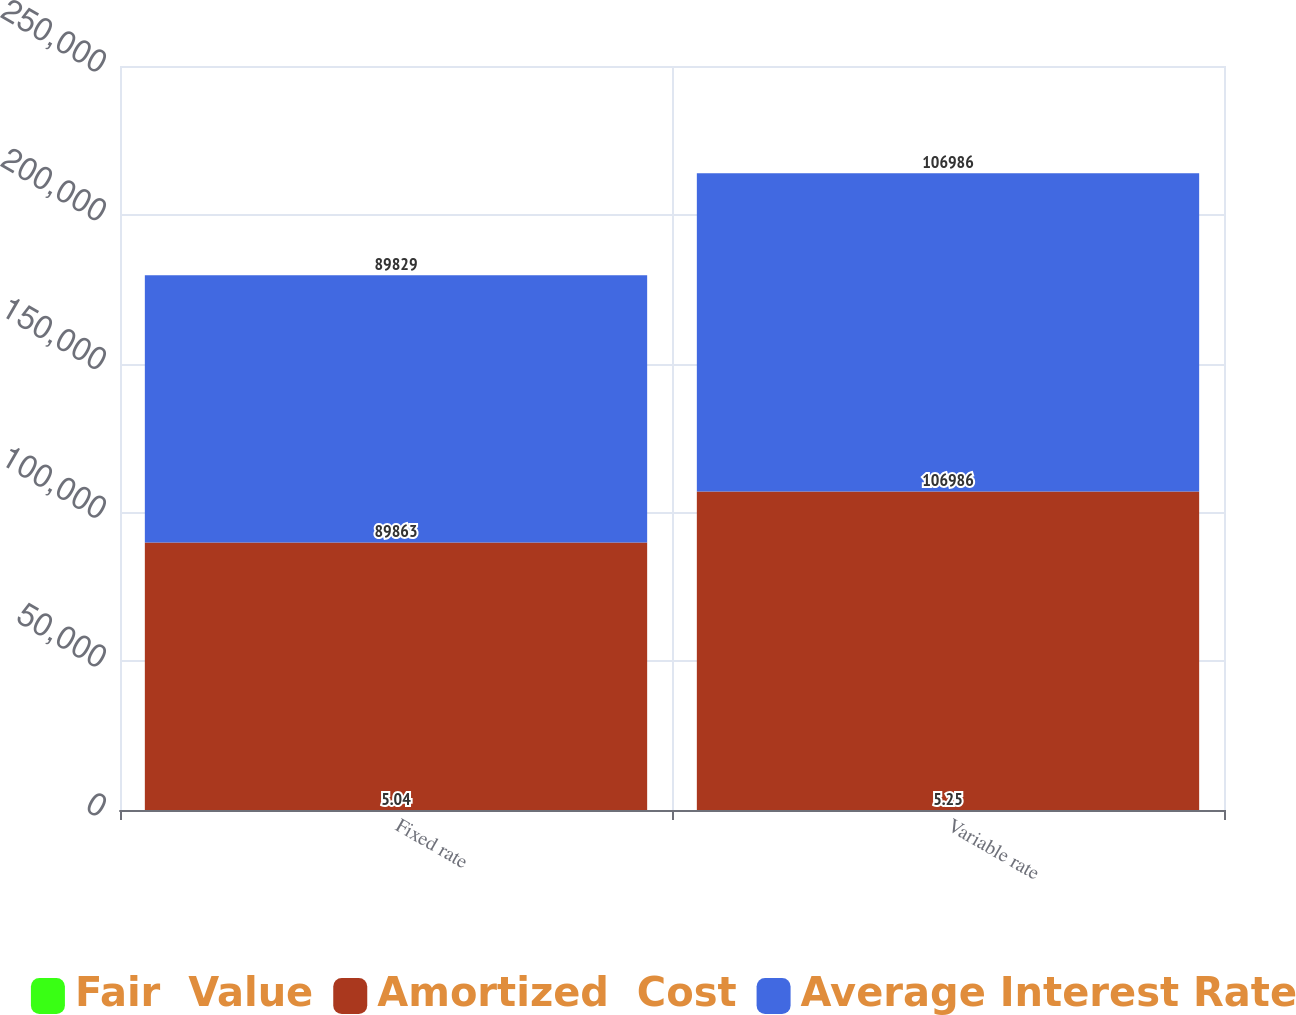<chart> <loc_0><loc_0><loc_500><loc_500><stacked_bar_chart><ecel><fcel>Fixed rate<fcel>Variable rate<nl><fcel>Fair  Value<fcel>5.04<fcel>5.25<nl><fcel>Amortized  Cost<fcel>89863<fcel>106986<nl><fcel>Average Interest Rate<fcel>89829<fcel>106986<nl></chart> 